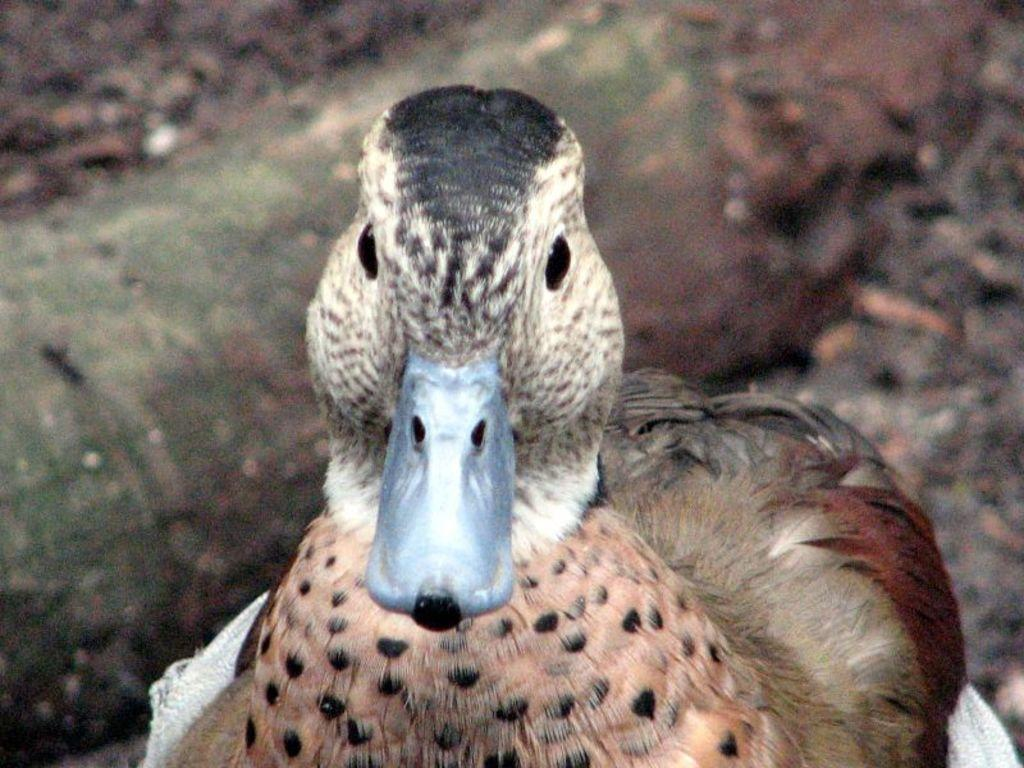What is located at the bottom of the image? There is a bird at the bottom of the image. Can you describe the background of the image? The background of the image is blurred. What type of argument is the bird having with the dinosaurs in the image? There are no dinosaurs present in the image, and therefore no argument can be observed. 